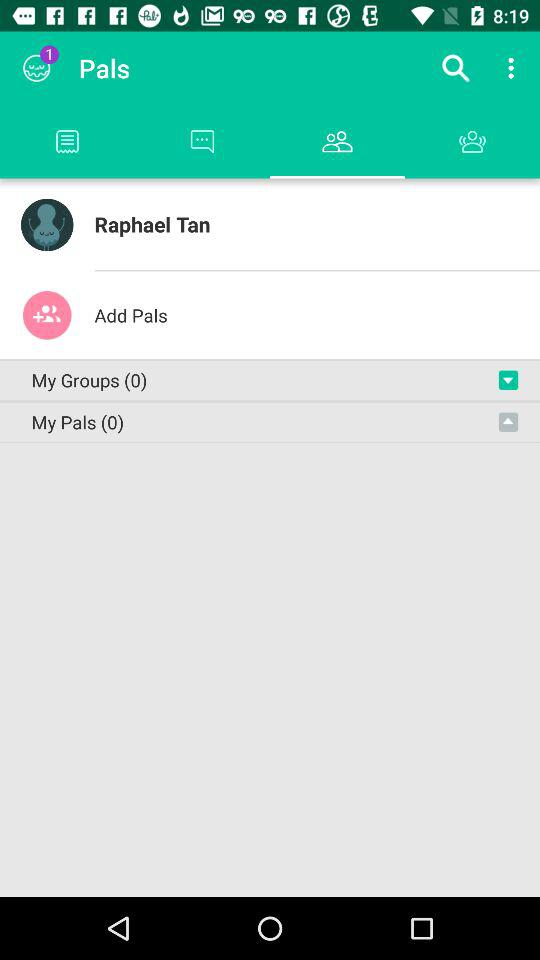How many "My Pals" are there? There are 0 "My Pals". 